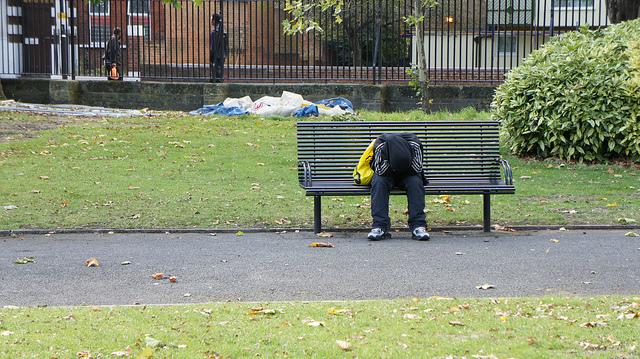Is the person on the bench stressed or tired?
Be succinct. Yes. What is the person sitting on?
Write a very short answer. Bench. Is it daytime?
Quick response, please. Yes. 